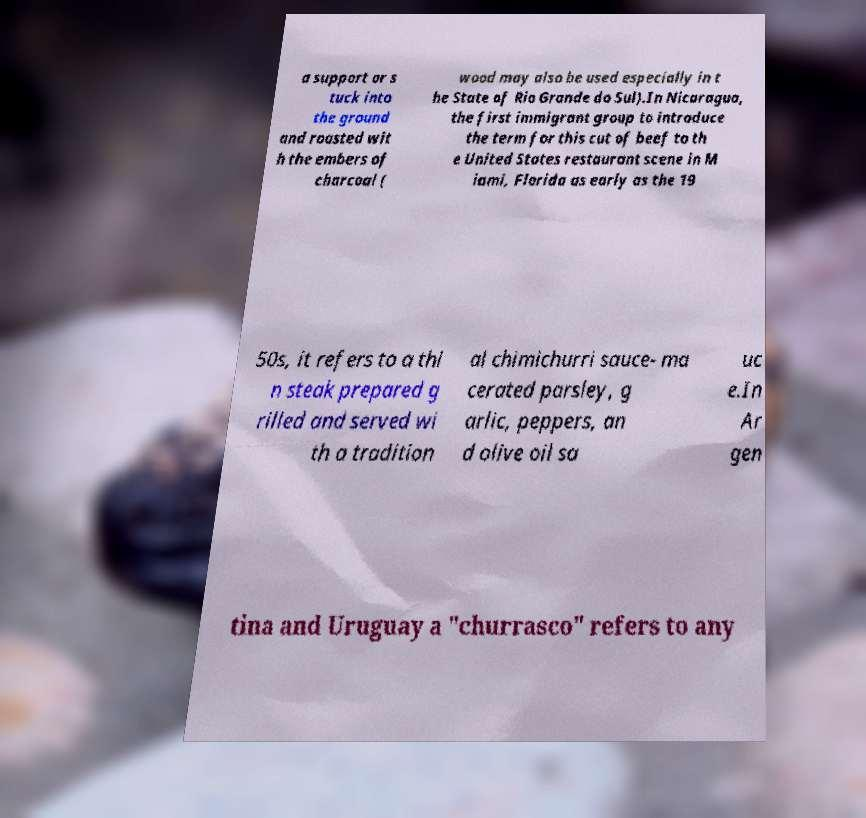I need the written content from this picture converted into text. Can you do that? a support or s tuck into the ground and roasted wit h the embers of charcoal ( wood may also be used especially in t he State of Rio Grande do Sul).In Nicaragua, the first immigrant group to introduce the term for this cut of beef to th e United States restaurant scene in M iami, Florida as early as the 19 50s, it refers to a thi n steak prepared g rilled and served wi th a tradition al chimichurri sauce- ma cerated parsley, g arlic, peppers, an d olive oil sa uc e.In Ar gen tina and Uruguay a "churrasco" refers to any 